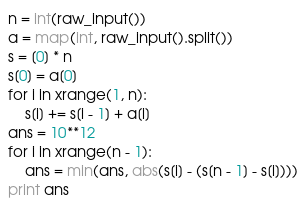<code> <loc_0><loc_0><loc_500><loc_500><_Python_>n = int(raw_input())
a = map(int, raw_input().split())
s = [0] * n
s[0] = a[0]
for i in xrange(1, n):
    s[i] += s[i - 1] + a[i]
ans = 10**12
for i in xrange(n - 1):
    ans = min(ans, abs(s[i] - (s[n - 1] - s[i])))
print ans</code> 